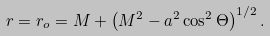<formula> <loc_0><loc_0><loc_500><loc_500>r = r _ { o } = M + \left ( M ^ { 2 } - a ^ { 2 } \cos ^ { 2 } \Theta \right ) ^ { 1 / 2 } .</formula> 